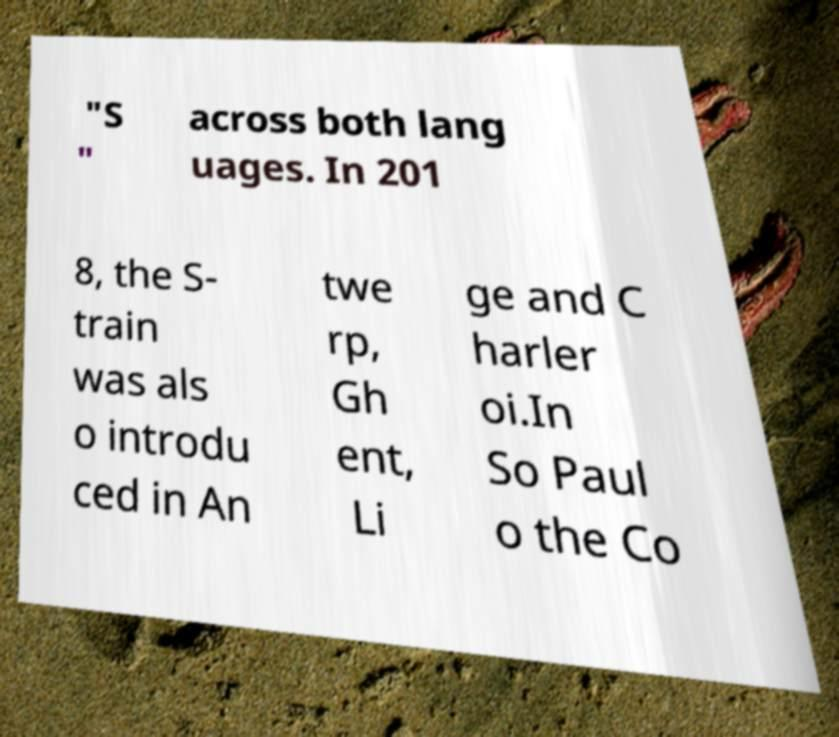What messages or text are displayed in this image? I need them in a readable, typed format. "S " across both lang uages. In 201 8, the S- train was als o introdu ced in An twe rp, Gh ent, Li ge and C harler oi.In So Paul o the Co 